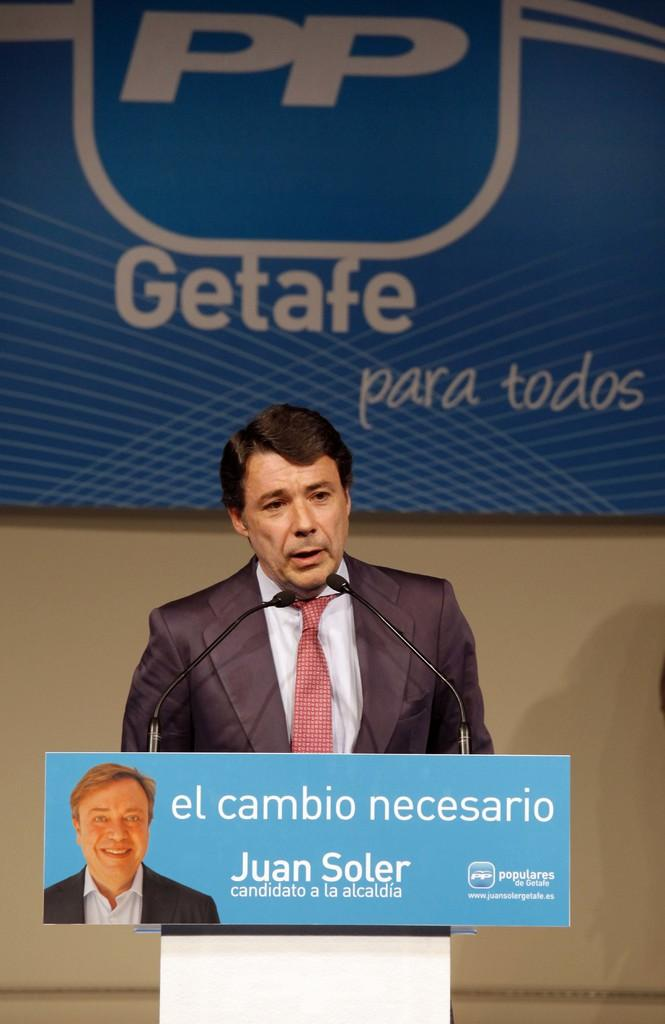What is the main subject of the image? There is a person in the image. What is the person wearing? The person is wearing a coat and a tie. What is the person doing in the image? The person is speaking. Where is the person standing? The person is standing in front of a stand. What can be seen on the stand? The stand has a hoarding and two microphones. What is visible in the background of the image? There is a hoarding on the wall in the background. How many owls are sitting on the person's shoulder in the image? There are no owls present in the image. What type of match is the person holding in the image? There is no match visible in the image. 